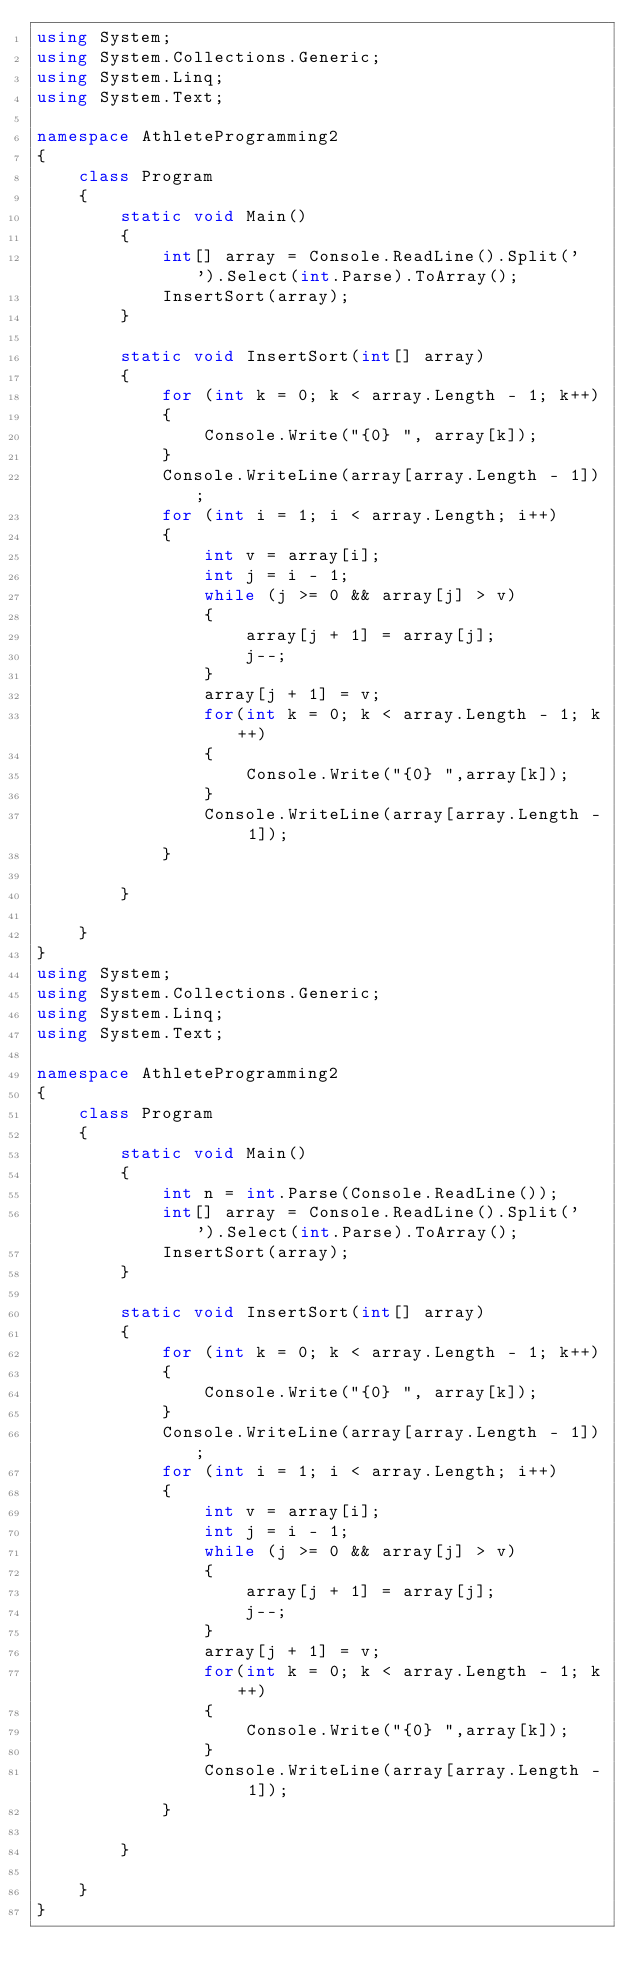Convert code to text. <code><loc_0><loc_0><loc_500><loc_500><_C#_>using System;
using System.Collections.Generic;
using System.Linq;
using System.Text;

namespace AthleteProgramming2
{
    class Program
    {
        static void Main()
        {
            int[] array = Console.ReadLine().Split(' ').Select(int.Parse).ToArray();
            InsertSort(array);
        }

        static void InsertSort(int[] array)
        {
            for (int k = 0; k < array.Length - 1; k++)
            {
                Console.Write("{0} ", array[k]);
            }
            Console.WriteLine(array[array.Length - 1]);
            for (int i = 1; i < array.Length; i++)
            {
                int v = array[i];
                int j = i - 1;
                while (j >= 0 && array[j] > v)
                {
                    array[j + 1] = array[j];
                    j--;
                }
                array[j + 1] = v;
                for(int k = 0; k < array.Length - 1; k++)
                {
                    Console.Write("{0} ",array[k]);
                }
                Console.WriteLine(array[array.Length - 1]);
            }
            
        }

    }
}
using System;
using System.Collections.Generic;
using System.Linq;
using System.Text;

namespace AthleteProgramming2
{
    class Program
    {
        static void Main()
        {
            int n = int.Parse(Console.ReadLine());
            int[] array = Console.ReadLine().Split(' ').Select(int.Parse).ToArray();
            InsertSort(array);
        }

        static void InsertSort(int[] array)
        {
            for (int k = 0; k < array.Length - 1; k++)
            {
                Console.Write("{0} ", array[k]);
            }
            Console.WriteLine(array[array.Length - 1]);
            for (int i = 1; i < array.Length; i++)
            {
                int v = array[i];
                int j = i - 1;
                while (j >= 0 && array[j] > v)
                {
                    array[j + 1] = array[j];
                    j--;
                }
                array[j + 1] = v;
                for(int k = 0; k < array.Length - 1; k++)
                {
                    Console.Write("{0} ",array[k]);
                }
                Console.WriteLine(array[array.Length - 1]);
            }
            
        }

    }
}</code> 